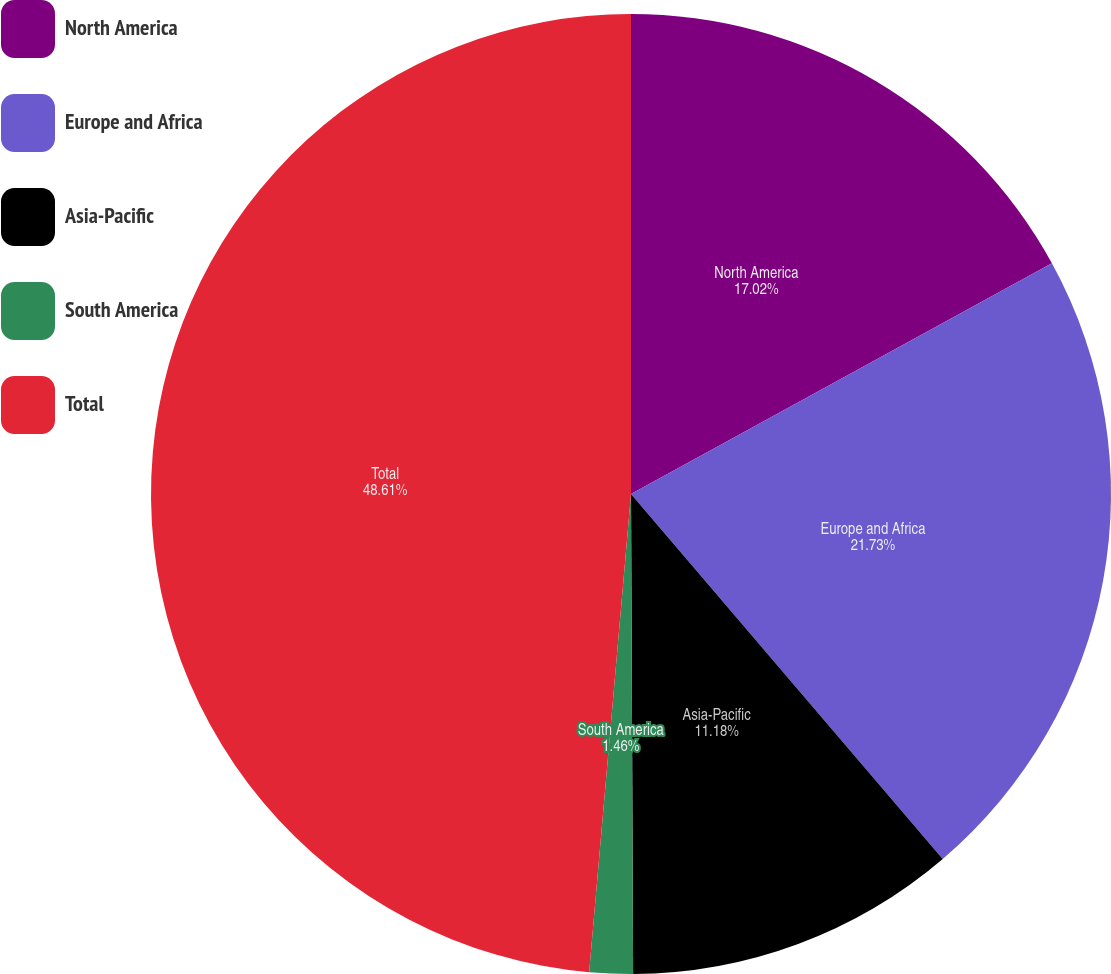Convert chart to OTSL. <chart><loc_0><loc_0><loc_500><loc_500><pie_chart><fcel>North America<fcel>Europe and Africa<fcel>Asia-Pacific<fcel>South America<fcel>Total<nl><fcel>17.02%<fcel>21.73%<fcel>11.18%<fcel>1.46%<fcel>48.61%<nl></chart> 